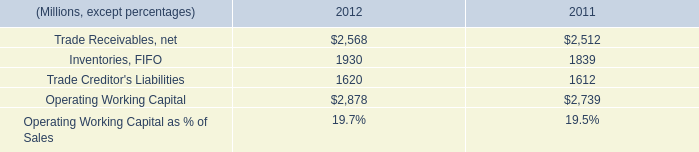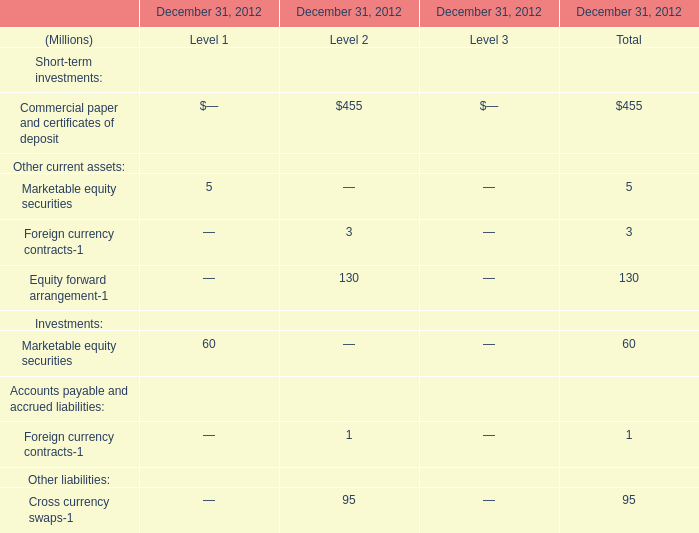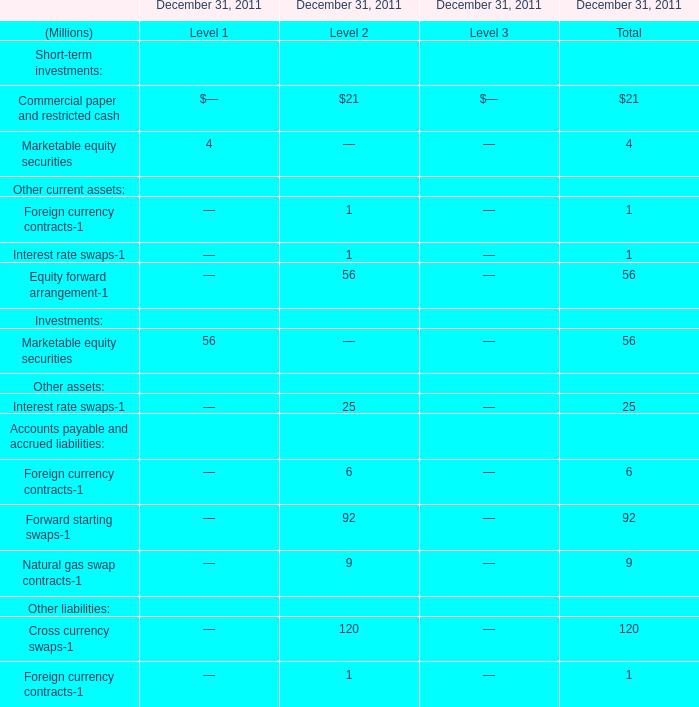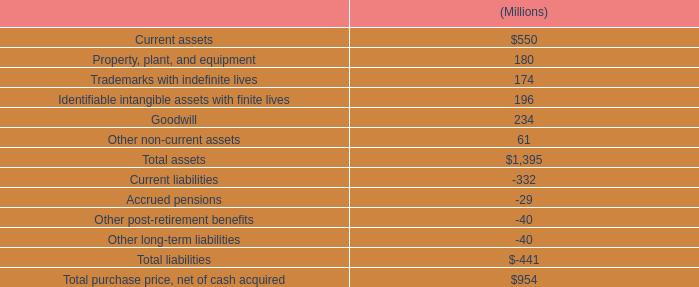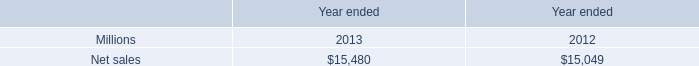what's the total amount of Net sales of Year ended 2013, and Trade Creditor's Liabilities of 2011 ? 
Computations: (15480.0 + 1612.0)
Answer: 17092.0. 